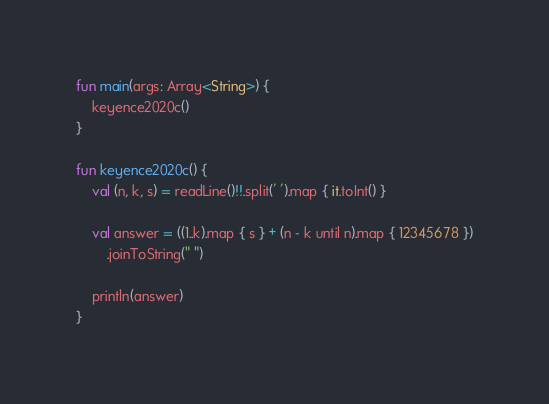<code> <loc_0><loc_0><loc_500><loc_500><_Kotlin_>fun main(args: Array<String>) {
    keyence2020c()
}

fun keyence2020c() {
    val (n, k, s) = readLine()!!.split(' ').map { it.toInt() }

    val answer = ((1..k).map { s } + (n - k until n).map { 12345678 })
        .joinToString(" ")

    println(answer)
}
</code> 